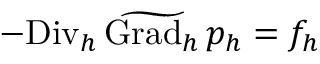<formula> <loc_0><loc_0><loc_500><loc_500>- { D i v _ { h } } \, \widetilde { G r a d _ { h } } \, p _ { h } = f _ { h }</formula> 